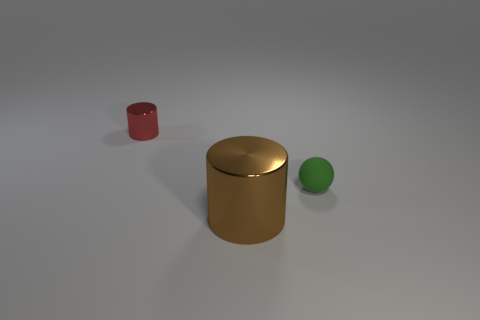What is the shape of the thing that is made of the same material as the large brown cylinder?
Offer a very short reply. Cylinder. Is there any other thing that is the same color as the ball?
Give a very brief answer. No. What is the color of the cylinder that is in front of the small green thing?
Give a very brief answer. Brown. Is the color of the small object on the left side of the tiny rubber object the same as the large object?
Offer a terse response. No. There is another brown thing that is the same shape as the tiny metallic object; what material is it?
Your answer should be very brief. Metal. What number of brown metallic things are the same size as the red cylinder?
Your response must be concise. 0. The small rubber object has what shape?
Keep it short and to the point. Sphere. There is a object that is both in front of the small red shiny object and behind the large brown metallic cylinder; what is its size?
Ensure brevity in your answer.  Small. There is a thing in front of the small green matte sphere; what is it made of?
Your answer should be compact. Metal. There is a big shiny object; is it the same color as the metallic cylinder that is behind the large brown cylinder?
Provide a short and direct response. No. 